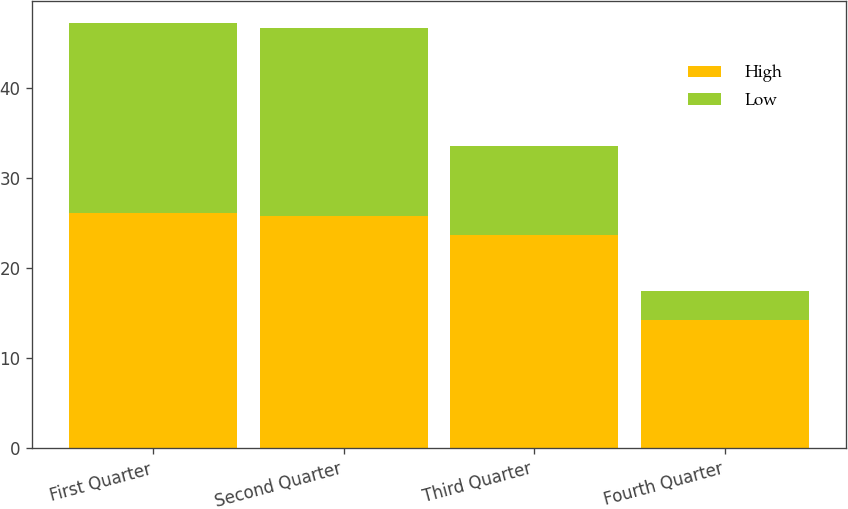Convert chart. <chart><loc_0><loc_0><loc_500><loc_500><stacked_bar_chart><ecel><fcel>First Quarter<fcel>Second Quarter<fcel>Third Quarter<fcel>Fourth Quarter<nl><fcel>High<fcel>26.08<fcel>25.79<fcel>23.63<fcel>14.26<nl><fcel>Low<fcel>21.11<fcel>20.82<fcel>9.92<fcel>3.15<nl></chart> 